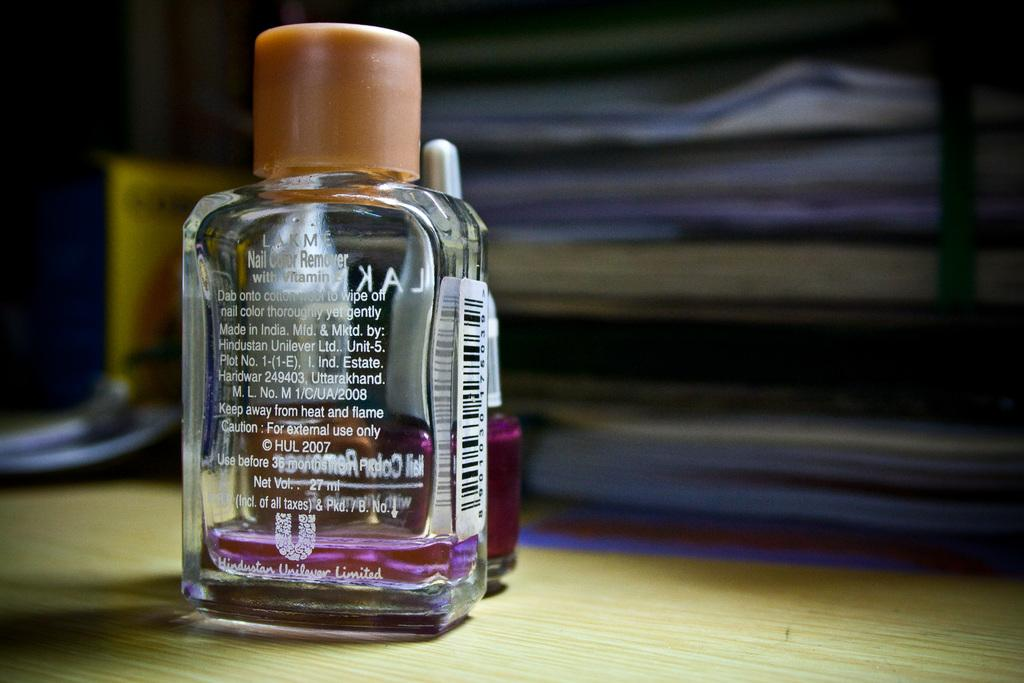<image>
Present a compact description of the photo's key features. A bottle of Lakme nail remover is in front of 2 bottle of nail polish. 